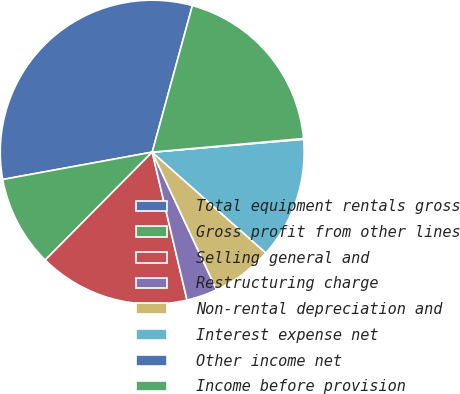Convert chart. <chart><loc_0><loc_0><loc_500><loc_500><pie_chart><fcel>Total equipment rentals gross<fcel>Gross profit from other lines<fcel>Selling general and<fcel>Restructuring charge<fcel>Non-rental depreciation and<fcel>Interest expense net<fcel>Other income net<fcel>Income before provision<nl><fcel>32.14%<fcel>9.69%<fcel>16.11%<fcel>3.28%<fcel>6.49%<fcel>12.9%<fcel>0.08%<fcel>19.31%<nl></chart> 